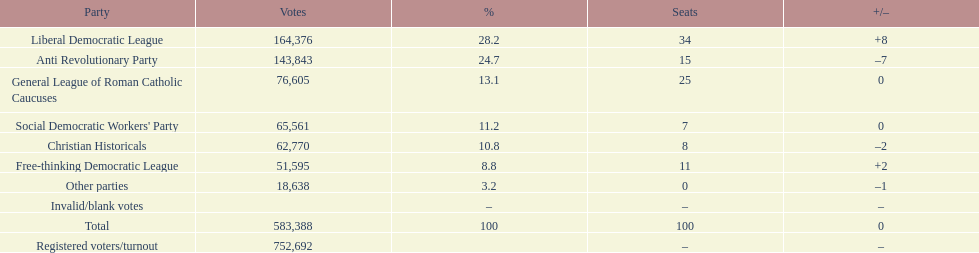How many votes were counted as invalid or blank votes? 0. 